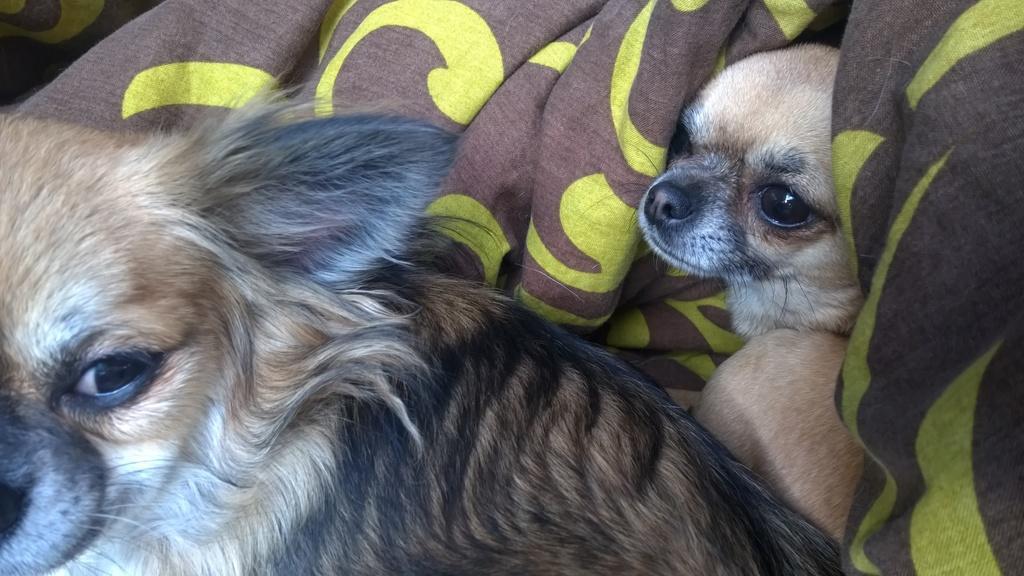Can you describe this image briefly? In this image we can see two puppies which are of brown color wrapped by a blanket which is of brown and yellow color. 